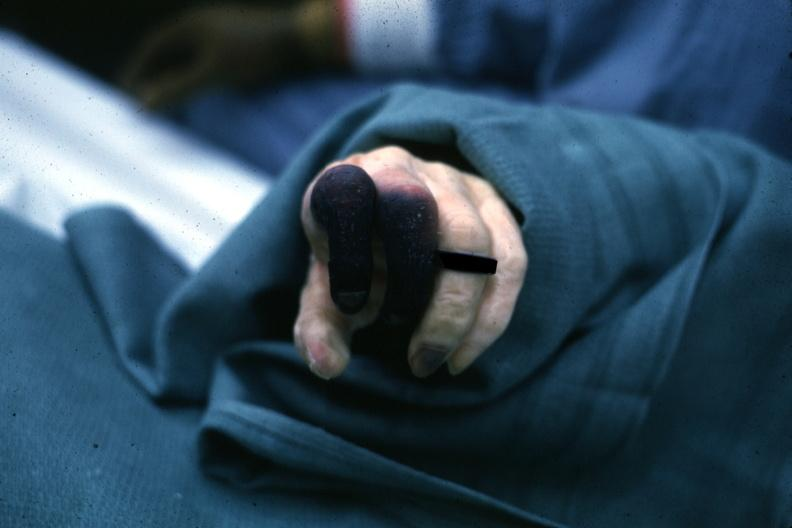does hemorrhage newborn show well shown gangrene fingers?
Answer the question using a single word or phrase. No 